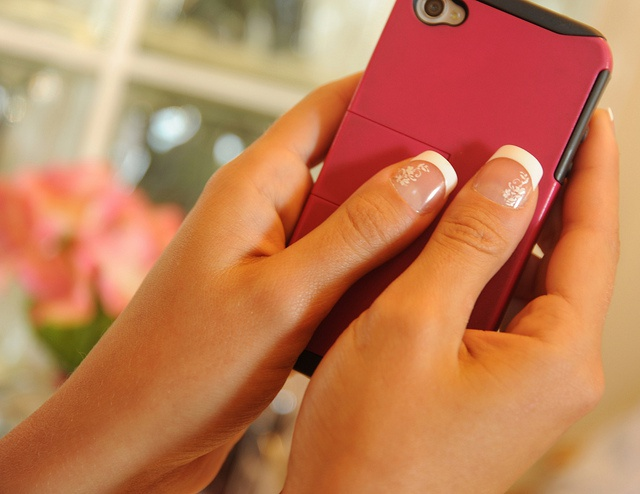Describe the objects in this image and their specific colors. I can see people in tan and red tones and cell phone in tan, brown, and maroon tones in this image. 